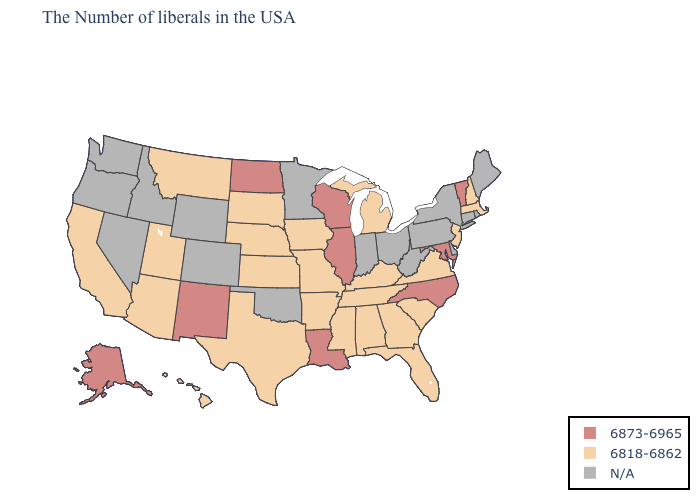Which states have the lowest value in the USA?
Keep it brief. Massachusetts, New Hampshire, New Jersey, Virginia, South Carolina, Florida, Georgia, Michigan, Kentucky, Alabama, Tennessee, Mississippi, Missouri, Arkansas, Iowa, Kansas, Nebraska, Texas, South Dakota, Utah, Montana, Arizona, California, Hawaii. Does Utah have the highest value in the West?
Write a very short answer. No. Which states have the highest value in the USA?
Concise answer only. Vermont, Maryland, North Carolina, Wisconsin, Illinois, Louisiana, North Dakota, New Mexico, Alaska. What is the lowest value in states that border Wisconsin?
Answer briefly. 6818-6862. Does the map have missing data?
Give a very brief answer. Yes. What is the value of Pennsylvania?
Short answer required. N/A. Name the states that have a value in the range 6818-6862?
Quick response, please. Massachusetts, New Hampshire, New Jersey, Virginia, South Carolina, Florida, Georgia, Michigan, Kentucky, Alabama, Tennessee, Mississippi, Missouri, Arkansas, Iowa, Kansas, Nebraska, Texas, South Dakota, Utah, Montana, Arizona, California, Hawaii. Does Illinois have the lowest value in the USA?
Concise answer only. No. What is the value of Virginia?
Answer briefly. 6818-6862. What is the value of Vermont?
Be succinct. 6873-6965. What is the value of New Mexico?
Quick response, please. 6873-6965. What is the value of Washington?
Be succinct. N/A. Name the states that have a value in the range 6818-6862?
Quick response, please. Massachusetts, New Hampshire, New Jersey, Virginia, South Carolina, Florida, Georgia, Michigan, Kentucky, Alabama, Tennessee, Mississippi, Missouri, Arkansas, Iowa, Kansas, Nebraska, Texas, South Dakota, Utah, Montana, Arizona, California, Hawaii. 